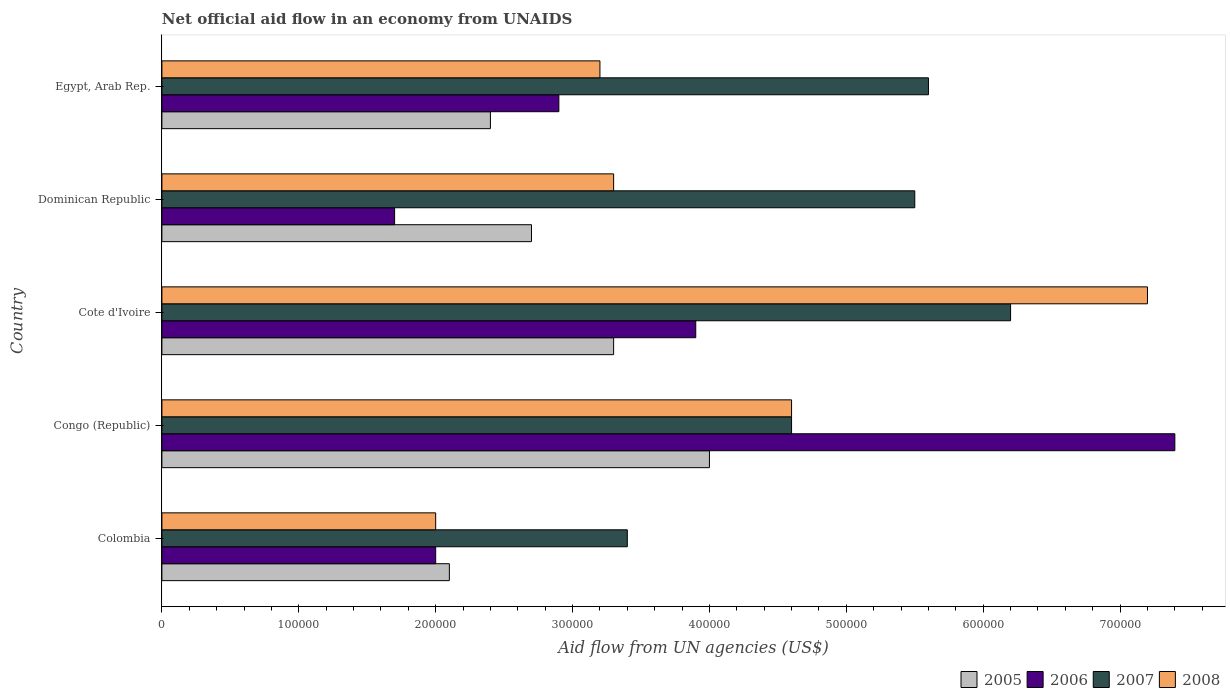How many different coloured bars are there?
Give a very brief answer. 4. Are the number of bars per tick equal to the number of legend labels?
Your answer should be compact. Yes. How many bars are there on the 2nd tick from the bottom?
Offer a terse response. 4. What is the label of the 3rd group of bars from the top?
Your response must be concise. Cote d'Ivoire. What is the net official aid flow in 2006 in Cote d'Ivoire?
Offer a very short reply. 3.90e+05. In which country was the net official aid flow in 2005 maximum?
Make the answer very short. Congo (Republic). What is the total net official aid flow in 2007 in the graph?
Your response must be concise. 2.53e+06. What is the difference between the net official aid flow in 2008 in Dominican Republic and the net official aid flow in 2006 in Cote d'Ivoire?
Offer a very short reply. -6.00e+04. What is the average net official aid flow in 2007 per country?
Give a very brief answer. 5.06e+05. What is the difference between the net official aid flow in 2007 and net official aid flow in 2008 in Egypt, Arab Rep.?
Ensure brevity in your answer.  2.40e+05. In how many countries, is the net official aid flow in 2005 greater than 360000 US$?
Your answer should be compact. 1. What is the ratio of the net official aid flow in 2008 in Congo (Republic) to that in Egypt, Arab Rep.?
Make the answer very short. 1.44. Is the difference between the net official aid flow in 2007 in Colombia and Cote d'Ivoire greater than the difference between the net official aid flow in 2008 in Colombia and Cote d'Ivoire?
Give a very brief answer. Yes. What is the difference between the highest and the lowest net official aid flow in 2007?
Ensure brevity in your answer.  2.80e+05. In how many countries, is the net official aid flow in 2008 greater than the average net official aid flow in 2008 taken over all countries?
Give a very brief answer. 2. Is it the case that in every country, the sum of the net official aid flow in 2008 and net official aid flow in 2006 is greater than the net official aid flow in 2005?
Your response must be concise. Yes. How many countries are there in the graph?
Make the answer very short. 5. What is the difference between two consecutive major ticks on the X-axis?
Your answer should be very brief. 1.00e+05. Does the graph contain grids?
Your answer should be compact. No. Where does the legend appear in the graph?
Your response must be concise. Bottom right. How many legend labels are there?
Your answer should be very brief. 4. How are the legend labels stacked?
Your response must be concise. Horizontal. What is the title of the graph?
Offer a very short reply. Net official aid flow in an economy from UNAIDS. What is the label or title of the X-axis?
Offer a very short reply. Aid flow from UN agencies (US$). What is the label or title of the Y-axis?
Ensure brevity in your answer.  Country. What is the Aid flow from UN agencies (US$) in 2006 in Colombia?
Provide a succinct answer. 2.00e+05. What is the Aid flow from UN agencies (US$) of 2006 in Congo (Republic)?
Provide a succinct answer. 7.40e+05. What is the Aid flow from UN agencies (US$) in 2007 in Congo (Republic)?
Provide a succinct answer. 4.60e+05. What is the Aid flow from UN agencies (US$) in 2006 in Cote d'Ivoire?
Provide a short and direct response. 3.90e+05. What is the Aid flow from UN agencies (US$) of 2007 in Cote d'Ivoire?
Give a very brief answer. 6.20e+05. What is the Aid flow from UN agencies (US$) in 2008 in Cote d'Ivoire?
Ensure brevity in your answer.  7.20e+05. What is the Aid flow from UN agencies (US$) in 2005 in Dominican Republic?
Give a very brief answer. 2.70e+05. What is the Aid flow from UN agencies (US$) in 2007 in Dominican Republic?
Offer a very short reply. 5.50e+05. What is the Aid flow from UN agencies (US$) of 2005 in Egypt, Arab Rep.?
Make the answer very short. 2.40e+05. What is the Aid flow from UN agencies (US$) in 2007 in Egypt, Arab Rep.?
Ensure brevity in your answer.  5.60e+05. What is the Aid flow from UN agencies (US$) of 2008 in Egypt, Arab Rep.?
Your answer should be very brief. 3.20e+05. Across all countries, what is the maximum Aid flow from UN agencies (US$) of 2005?
Provide a short and direct response. 4.00e+05. Across all countries, what is the maximum Aid flow from UN agencies (US$) in 2006?
Provide a succinct answer. 7.40e+05. Across all countries, what is the maximum Aid flow from UN agencies (US$) of 2007?
Keep it short and to the point. 6.20e+05. Across all countries, what is the maximum Aid flow from UN agencies (US$) in 2008?
Offer a terse response. 7.20e+05. Across all countries, what is the minimum Aid flow from UN agencies (US$) in 2006?
Offer a very short reply. 1.70e+05. Across all countries, what is the minimum Aid flow from UN agencies (US$) in 2008?
Ensure brevity in your answer.  2.00e+05. What is the total Aid flow from UN agencies (US$) in 2005 in the graph?
Provide a succinct answer. 1.45e+06. What is the total Aid flow from UN agencies (US$) of 2006 in the graph?
Ensure brevity in your answer.  1.79e+06. What is the total Aid flow from UN agencies (US$) of 2007 in the graph?
Offer a terse response. 2.53e+06. What is the total Aid flow from UN agencies (US$) of 2008 in the graph?
Give a very brief answer. 2.03e+06. What is the difference between the Aid flow from UN agencies (US$) of 2005 in Colombia and that in Congo (Republic)?
Make the answer very short. -1.90e+05. What is the difference between the Aid flow from UN agencies (US$) of 2006 in Colombia and that in Congo (Republic)?
Offer a terse response. -5.40e+05. What is the difference between the Aid flow from UN agencies (US$) of 2006 in Colombia and that in Cote d'Ivoire?
Ensure brevity in your answer.  -1.90e+05. What is the difference between the Aid flow from UN agencies (US$) in 2007 in Colombia and that in Cote d'Ivoire?
Your answer should be very brief. -2.80e+05. What is the difference between the Aid flow from UN agencies (US$) of 2008 in Colombia and that in Cote d'Ivoire?
Your answer should be compact. -5.20e+05. What is the difference between the Aid flow from UN agencies (US$) of 2006 in Colombia and that in Dominican Republic?
Offer a very short reply. 3.00e+04. What is the difference between the Aid flow from UN agencies (US$) in 2007 in Colombia and that in Dominican Republic?
Make the answer very short. -2.10e+05. What is the difference between the Aid flow from UN agencies (US$) of 2008 in Colombia and that in Dominican Republic?
Give a very brief answer. -1.30e+05. What is the difference between the Aid flow from UN agencies (US$) in 2005 in Colombia and that in Egypt, Arab Rep.?
Your response must be concise. -3.00e+04. What is the difference between the Aid flow from UN agencies (US$) in 2006 in Colombia and that in Egypt, Arab Rep.?
Your answer should be very brief. -9.00e+04. What is the difference between the Aid flow from UN agencies (US$) of 2007 in Colombia and that in Egypt, Arab Rep.?
Provide a succinct answer. -2.20e+05. What is the difference between the Aid flow from UN agencies (US$) of 2008 in Colombia and that in Egypt, Arab Rep.?
Provide a succinct answer. -1.20e+05. What is the difference between the Aid flow from UN agencies (US$) in 2005 in Congo (Republic) and that in Cote d'Ivoire?
Ensure brevity in your answer.  7.00e+04. What is the difference between the Aid flow from UN agencies (US$) in 2007 in Congo (Republic) and that in Cote d'Ivoire?
Keep it short and to the point. -1.60e+05. What is the difference between the Aid flow from UN agencies (US$) in 2008 in Congo (Republic) and that in Cote d'Ivoire?
Your answer should be compact. -2.60e+05. What is the difference between the Aid flow from UN agencies (US$) in 2006 in Congo (Republic) and that in Dominican Republic?
Your answer should be compact. 5.70e+05. What is the difference between the Aid flow from UN agencies (US$) of 2008 in Congo (Republic) and that in Egypt, Arab Rep.?
Your response must be concise. 1.40e+05. What is the difference between the Aid flow from UN agencies (US$) of 2005 in Cote d'Ivoire and that in Dominican Republic?
Your response must be concise. 6.00e+04. What is the difference between the Aid flow from UN agencies (US$) of 2006 in Cote d'Ivoire and that in Dominican Republic?
Offer a very short reply. 2.20e+05. What is the difference between the Aid flow from UN agencies (US$) in 2007 in Cote d'Ivoire and that in Dominican Republic?
Provide a short and direct response. 7.00e+04. What is the difference between the Aid flow from UN agencies (US$) of 2008 in Cote d'Ivoire and that in Egypt, Arab Rep.?
Offer a terse response. 4.00e+05. What is the difference between the Aid flow from UN agencies (US$) of 2005 in Dominican Republic and that in Egypt, Arab Rep.?
Provide a short and direct response. 3.00e+04. What is the difference between the Aid flow from UN agencies (US$) in 2007 in Dominican Republic and that in Egypt, Arab Rep.?
Your answer should be compact. -10000. What is the difference between the Aid flow from UN agencies (US$) of 2008 in Dominican Republic and that in Egypt, Arab Rep.?
Your response must be concise. 10000. What is the difference between the Aid flow from UN agencies (US$) of 2005 in Colombia and the Aid flow from UN agencies (US$) of 2006 in Congo (Republic)?
Give a very brief answer. -5.30e+05. What is the difference between the Aid flow from UN agencies (US$) of 2005 in Colombia and the Aid flow from UN agencies (US$) of 2007 in Congo (Republic)?
Your response must be concise. -2.50e+05. What is the difference between the Aid flow from UN agencies (US$) of 2006 in Colombia and the Aid flow from UN agencies (US$) of 2007 in Congo (Republic)?
Offer a very short reply. -2.60e+05. What is the difference between the Aid flow from UN agencies (US$) in 2006 in Colombia and the Aid flow from UN agencies (US$) in 2008 in Congo (Republic)?
Keep it short and to the point. -2.60e+05. What is the difference between the Aid flow from UN agencies (US$) of 2007 in Colombia and the Aid flow from UN agencies (US$) of 2008 in Congo (Republic)?
Your answer should be very brief. -1.20e+05. What is the difference between the Aid flow from UN agencies (US$) of 2005 in Colombia and the Aid flow from UN agencies (US$) of 2006 in Cote d'Ivoire?
Give a very brief answer. -1.80e+05. What is the difference between the Aid flow from UN agencies (US$) of 2005 in Colombia and the Aid flow from UN agencies (US$) of 2007 in Cote d'Ivoire?
Ensure brevity in your answer.  -4.10e+05. What is the difference between the Aid flow from UN agencies (US$) in 2005 in Colombia and the Aid flow from UN agencies (US$) in 2008 in Cote d'Ivoire?
Offer a terse response. -5.10e+05. What is the difference between the Aid flow from UN agencies (US$) in 2006 in Colombia and the Aid flow from UN agencies (US$) in 2007 in Cote d'Ivoire?
Your answer should be compact. -4.20e+05. What is the difference between the Aid flow from UN agencies (US$) in 2006 in Colombia and the Aid flow from UN agencies (US$) in 2008 in Cote d'Ivoire?
Offer a very short reply. -5.20e+05. What is the difference between the Aid flow from UN agencies (US$) of 2007 in Colombia and the Aid flow from UN agencies (US$) of 2008 in Cote d'Ivoire?
Your answer should be very brief. -3.80e+05. What is the difference between the Aid flow from UN agencies (US$) of 2005 in Colombia and the Aid flow from UN agencies (US$) of 2006 in Dominican Republic?
Provide a succinct answer. 4.00e+04. What is the difference between the Aid flow from UN agencies (US$) of 2006 in Colombia and the Aid flow from UN agencies (US$) of 2007 in Dominican Republic?
Give a very brief answer. -3.50e+05. What is the difference between the Aid flow from UN agencies (US$) in 2005 in Colombia and the Aid flow from UN agencies (US$) in 2007 in Egypt, Arab Rep.?
Your response must be concise. -3.50e+05. What is the difference between the Aid flow from UN agencies (US$) in 2005 in Colombia and the Aid flow from UN agencies (US$) in 2008 in Egypt, Arab Rep.?
Keep it short and to the point. -1.10e+05. What is the difference between the Aid flow from UN agencies (US$) of 2006 in Colombia and the Aid flow from UN agencies (US$) of 2007 in Egypt, Arab Rep.?
Offer a terse response. -3.60e+05. What is the difference between the Aid flow from UN agencies (US$) of 2005 in Congo (Republic) and the Aid flow from UN agencies (US$) of 2007 in Cote d'Ivoire?
Provide a succinct answer. -2.20e+05. What is the difference between the Aid flow from UN agencies (US$) in 2005 in Congo (Republic) and the Aid flow from UN agencies (US$) in 2008 in Cote d'Ivoire?
Provide a short and direct response. -3.20e+05. What is the difference between the Aid flow from UN agencies (US$) of 2006 in Congo (Republic) and the Aid flow from UN agencies (US$) of 2007 in Cote d'Ivoire?
Your answer should be compact. 1.20e+05. What is the difference between the Aid flow from UN agencies (US$) of 2006 in Congo (Republic) and the Aid flow from UN agencies (US$) of 2008 in Cote d'Ivoire?
Your answer should be very brief. 2.00e+04. What is the difference between the Aid flow from UN agencies (US$) in 2005 in Congo (Republic) and the Aid flow from UN agencies (US$) in 2008 in Dominican Republic?
Provide a short and direct response. 7.00e+04. What is the difference between the Aid flow from UN agencies (US$) in 2006 in Congo (Republic) and the Aid flow from UN agencies (US$) in 2008 in Dominican Republic?
Your answer should be compact. 4.10e+05. What is the difference between the Aid flow from UN agencies (US$) of 2007 in Congo (Republic) and the Aid flow from UN agencies (US$) of 2008 in Dominican Republic?
Provide a succinct answer. 1.30e+05. What is the difference between the Aid flow from UN agencies (US$) of 2005 in Congo (Republic) and the Aid flow from UN agencies (US$) of 2008 in Egypt, Arab Rep.?
Your response must be concise. 8.00e+04. What is the difference between the Aid flow from UN agencies (US$) of 2005 in Cote d'Ivoire and the Aid flow from UN agencies (US$) of 2007 in Dominican Republic?
Your response must be concise. -2.20e+05. What is the difference between the Aid flow from UN agencies (US$) of 2006 in Cote d'Ivoire and the Aid flow from UN agencies (US$) of 2007 in Dominican Republic?
Your response must be concise. -1.60e+05. What is the difference between the Aid flow from UN agencies (US$) in 2005 in Cote d'Ivoire and the Aid flow from UN agencies (US$) in 2006 in Egypt, Arab Rep.?
Your answer should be compact. 4.00e+04. What is the difference between the Aid flow from UN agencies (US$) of 2005 in Cote d'Ivoire and the Aid flow from UN agencies (US$) of 2007 in Egypt, Arab Rep.?
Offer a very short reply. -2.30e+05. What is the difference between the Aid flow from UN agencies (US$) in 2005 in Cote d'Ivoire and the Aid flow from UN agencies (US$) in 2008 in Egypt, Arab Rep.?
Offer a very short reply. 10000. What is the difference between the Aid flow from UN agencies (US$) in 2006 in Cote d'Ivoire and the Aid flow from UN agencies (US$) in 2007 in Egypt, Arab Rep.?
Your answer should be very brief. -1.70e+05. What is the difference between the Aid flow from UN agencies (US$) in 2007 in Cote d'Ivoire and the Aid flow from UN agencies (US$) in 2008 in Egypt, Arab Rep.?
Your response must be concise. 3.00e+05. What is the difference between the Aid flow from UN agencies (US$) in 2006 in Dominican Republic and the Aid flow from UN agencies (US$) in 2007 in Egypt, Arab Rep.?
Provide a succinct answer. -3.90e+05. What is the difference between the Aid flow from UN agencies (US$) in 2006 in Dominican Republic and the Aid flow from UN agencies (US$) in 2008 in Egypt, Arab Rep.?
Offer a terse response. -1.50e+05. What is the difference between the Aid flow from UN agencies (US$) in 2007 in Dominican Republic and the Aid flow from UN agencies (US$) in 2008 in Egypt, Arab Rep.?
Your answer should be compact. 2.30e+05. What is the average Aid flow from UN agencies (US$) of 2005 per country?
Keep it short and to the point. 2.90e+05. What is the average Aid flow from UN agencies (US$) of 2006 per country?
Your answer should be compact. 3.58e+05. What is the average Aid flow from UN agencies (US$) of 2007 per country?
Keep it short and to the point. 5.06e+05. What is the average Aid flow from UN agencies (US$) of 2008 per country?
Provide a short and direct response. 4.06e+05. What is the difference between the Aid flow from UN agencies (US$) of 2005 and Aid flow from UN agencies (US$) of 2007 in Colombia?
Your response must be concise. -1.30e+05. What is the difference between the Aid flow from UN agencies (US$) of 2006 and Aid flow from UN agencies (US$) of 2007 in Colombia?
Offer a very short reply. -1.40e+05. What is the difference between the Aid flow from UN agencies (US$) in 2005 and Aid flow from UN agencies (US$) in 2006 in Congo (Republic)?
Keep it short and to the point. -3.40e+05. What is the difference between the Aid flow from UN agencies (US$) of 2005 and Aid flow from UN agencies (US$) of 2007 in Congo (Republic)?
Your answer should be compact. -6.00e+04. What is the difference between the Aid flow from UN agencies (US$) of 2006 and Aid flow from UN agencies (US$) of 2008 in Congo (Republic)?
Your answer should be very brief. 2.80e+05. What is the difference between the Aid flow from UN agencies (US$) of 2005 and Aid flow from UN agencies (US$) of 2006 in Cote d'Ivoire?
Give a very brief answer. -6.00e+04. What is the difference between the Aid flow from UN agencies (US$) of 2005 and Aid flow from UN agencies (US$) of 2008 in Cote d'Ivoire?
Offer a very short reply. -3.90e+05. What is the difference between the Aid flow from UN agencies (US$) in 2006 and Aid flow from UN agencies (US$) in 2008 in Cote d'Ivoire?
Your answer should be very brief. -3.30e+05. What is the difference between the Aid flow from UN agencies (US$) of 2007 and Aid flow from UN agencies (US$) of 2008 in Cote d'Ivoire?
Provide a short and direct response. -1.00e+05. What is the difference between the Aid flow from UN agencies (US$) in 2005 and Aid flow from UN agencies (US$) in 2007 in Dominican Republic?
Your answer should be very brief. -2.80e+05. What is the difference between the Aid flow from UN agencies (US$) in 2006 and Aid flow from UN agencies (US$) in 2007 in Dominican Republic?
Provide a short and direct response. -3.80e+05. What is the difference between the Aid flow from UN agencies (US$) in 2005 and Aid flow from UN agencies (US$) in 2007 in Egypt, Arab Rep.?
Offer a terse response. -3.20e+05. What is the difference between the Aid flow from UN agencies (US$) of 2006 and Aid flow from UN agencies (US$) of 2008 in Egypt, Arab Rep.?
Your response must be concise. -3.00e+04. What is the difference between the Aid flow from UN agencies (US$) of 2007 and Aid flow from UN agencies (US$) of 2008 in Egypt, Arab Rep.?
Keep it short and to the point. 2.40e+05. What is the ratio of the Aid flow from UN agencies (US$) of 2005 in Colombia to that in Congo (Republic)?
Keep it short and to the point. 0.53. What is the ratio of the Aid flow from UN agencies (US$) of 2006 in Colombia to that in Congo (Republic)?
Offer a very short reply. 0.27. What is the ratio of the Aid flow from UN agencies (US$) in 2007 in Colombia to that in Congo (Republic)?
Offer a very short reply. 0.74. What is the ratio of the Aid flow from UN agencies (US$) in 2008 in Colombia to that in Congo (Republic)?
Your response must be concise. 0.43. What is the ratio of the Aid flow from UN agencies (US$) in 2005 in Colombia to that in Cote d'Ivoire?
Make the answer very short. 0.64. What is the ratio of the Aid flow from UN agencies (US$) in 2006 in Colombia to that in Cote d'Ivoire?
Keep it short and to the point. 0.51. What is the ratio of the Aid flow from UN agencies (US$) of 2007 in Colombia to that in Cote d'Ivoire?
Make the answer very short. 0.55. What is the ratio of the Aid flow from UN agencies (US$) in 2008 in Colombia to that in Cote d'Ivoire?
Provide a succinct answer. 0.28. What is the ratio of the Aid flow from UN agencies (US$) in 2006 in Colombia to that in Dominican Republic?
Keep it short and to the point. 1.18. What is the ratio of the Aid flow from UN agencies (US$) of 2007 in Colombia to that in Dominican Republic?
Your answer should be compact. 0.62. What is the ratio of the Aid flow from UN agencies (US$) in 2008 in Colombia to that in Dominican Republic?
Your response must be concise. 0.61. What is the ratio of the Aid flow from UN agencies (US$) in 2005 in Colombia to that in Egypt, Arab Rep.?
Offer a terse response. 0.88. What is the ratio of the Aid flow from UN agencies (US$) in 2006 in Colombia to that in Egypt, Arab Rep.?
Your answer should be compact. 0.69. What is the ratio of the Aid flow from UN agencies (US$) of 2007 in Colombia to that in Egypt, Arab Rep.?
Ensure brevity in your answer.  0.61. What is the ratio of the Aid flow from UN agencies (US$) in 2008 in Colombia to that in Egypt, Arab Rep.?
Offer a terse response. 0.62. What is the ratio of the Aid flow from UN agencies (US$) of 2005 in Congo (Republic) to that in Cote d'Ivoire?
Give a very brief answer. 1.21. What is the ratio of the Aid flow from UN agencies (US$) of 2006 in Congo (Republic) to that in Cote d'Ivoire?
Ensure brevity in your answer.  1.9. What is the ratio of the Aid flow from UN agencies (US$) in 2007 in Congo (Republic) to that in Cote d'Ivoire?
Offer a terse response. 0.74. What is the ratio of the Aid flow from UN agencies (US$) in 2008 in Congo (Republic) to that in Cote d'Ivoire?
Give a very brief answer. 0.64. What is the ratio of the Aid flow from UN agencies (US$) of 2005 in Congo (Republic) to that in Dominican Republic?
Provide a short and direct response. 1.48. What is the ratio of the Aid flow from UN agencies (US$) of 2006 in Congo (Republic) to that in Dominican Republic?
Make the answer very short. 4.35. What is the ratio of the Aid flow from UN agencies (US$) of 2007 in Congo (Republic) to that in Dominican Republic?
Make the answer very short. 0.84. What is the ratio of the Aid flow from UN agencies (US$) of 2008 in Congo (Republic) to that in Dominican Republic?
Your response must be concise. 1.39. What is the ratio of the Aid flow from UN agencies (US$) of 2005 in Congo (Republic) to that in Egypt, Arab Rep.?
Ensure brevity in your answer.  1.67. What is the ratio of the Aid flow from UN agencies (US$) of 2006 in Congo (Republic) to that in Egypt, Arab Rep.?
Provide a short and direct response. 2.55. What is the ratio of the Aid flow from UN agencies (US$) in 2007 in Congo (Republic) to that in Egypt, Arab Rep.?
Your answer should be compact. 0.82. What is the ratio of the Aid flow from UN agencies (US$) in 2008 in Congo (Republic) to that in Egypt, Arab Rep.?
Provide a short and direct response. 1.44. What is the ratio of the Aid flow from UN agencies (US$) of 2005 in Cote d'Ivoire to that in Dominican Republic?
Ensure brevity in your answer.  1.22. What is the ratio of the Aid flow from UN agencies (US$) in 2006 in Cote d'Ivoire to that in Dominican Republic?
Offer a terse response. 2.29. What is the ratio of the Aid flow from UN agencies (US$) of 2007 in Cote d'Ivoire to that in Dominican Republic?
Make the answer very short. 1.13. What is the ratio of the Aid flow from UN agencies (US$) of 2008 in Cote d'Ivoire to that in Dominican Republic?
Your answer should be compact. 2.18. What is the ratio of the Aid flow from UN agencies (US$) in 2005 in Cote d'Ivoire to that in Egypt, Arab Rep.?
Offer a terse response. 1.38. What is the ratio of the Aid flow from UN agencies (US$) in 2006 in Cote d'Ivoire to that in Egypt, Arab Rep.?
Make the answer very short. 1.34. What is the ratio of the Aid flow from UN agencies (US$) in 2007 in Cote d'Ivoire to that in Egypt, Arab Rep.?
Your answer should be compact. 1.11. What is the ratio of the Aid flow from UN agencies (US$) in 2008 in Cote d'Ivoire to that in Egypt, Arab Rep.?
Ensure brevity in your answer.  2.25. What is the ratio of the Aid flow from UN agencies (US$) in 2006 in Dominican Republic to that in Egypt, Arab Rep.?
Offer a very short reply. 0.59. What is the ratio of the Aid flow from UN agencies (US$) of 2007 in Dominican Republic to that in Egypt, Arab Rep.?
Provide a succinct answer. 0.98. What is the ratio of the Aid flow from UN agencies (US$) of 2008 in Dominican Republic to that in Egypt, Arab Rep.?
Give a very brief answer. 1.03. What is the difference between the highest and the second highest Aid flow from UN agencies (US$) of 2005?
Provide a succinct answer. 7.00e+04. What is the difference between the highest and the second highest Aid flow from UN agencies (US$) in 2008?
Offer a terse response. 2.60e+05. What is the difference between the highest and the lowest Aid flow from UN agencies (US$) in 2006?
Ensure brevity in your answer.  5.70e+05. What is the difference between the highest and the lowest Aid flow from UN agencies (US$) of 2008?
Keep it short and to the point. 5.20e+05. 